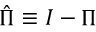Convert formula to latex. <formula><loc_0><loc_0><loc_500><loc_500>{ \hat { \Pi } } \equiv I - \Pi</formula> 